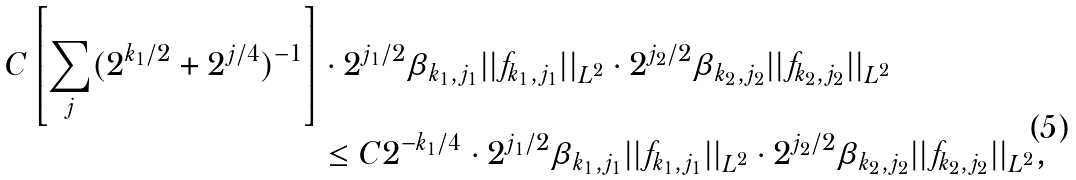Convert formula to latex. <formula><loc_0><loc_0><loc_500><loc_500>C \left [ \sum _ { j } ( 2 ^ { k _ { 1 } / 2 } + 2 ^ { j / 4 } ) ^ { - 1 } \right ] & \cdot 2 ^ { j _ { 1 } / 2 } \beta _ { k _ { 1 } , j _ { 1 } } | | f _ { k _ { 1 } , j _ { 1 } } | | _ { L ^ { 2 } } \cdot 2 ^ { j _ { 2 } / 2 } \beta _ { k _ { 2 } , j _ { 2 } } | | f _ { k _ { 2 } , j _ { 2 } } | | _ { L ^ { 2 } } \\ & \leq C 2 ^ { - k _ { 1 } / 4 } \cdot 2 ^ { j _ { 1 } / 2 } \beta _ { k _ { 1 } , j _ { 1 } } | | f _ { k _ { 1 } , j _ { 1 } } | | _ { L ^ { 2 } } \cdot 2 ^ { j _ { 2 } / 2 } \beta _ { k _ { 2 } , j _ { 2 } } | | f _ { k _ { 2 } , j _ { 2 } } | | _ { L ^ { 2 } } ,</formula> 